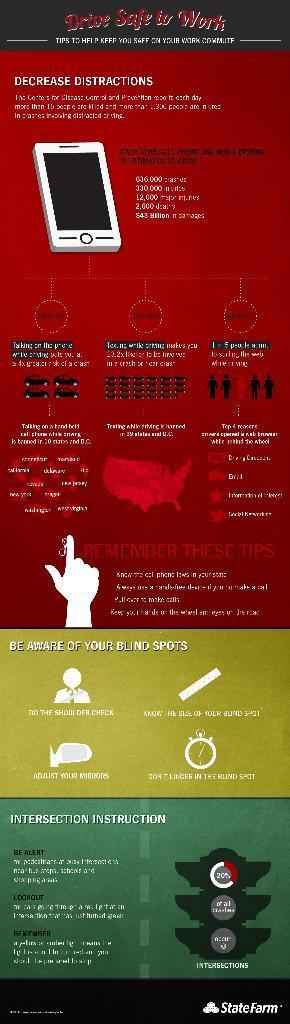Can you describe this image briefly? In this image we can see a poster with text and images. 